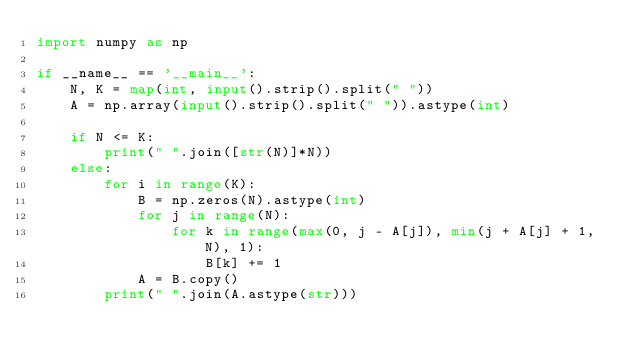<code> <loc_0><loc_0><loc_500><loc_500><_Python_>import numpy as np

if __name__ == '__main__':
    N, K = map(int, input().strip().split(" "))
    A = np.array(input().strip().split(" ")).astype(int)

    if N <= K:
        print(" ".join([str(N)]*N))
    else:
        for i in range(K):
            B = np.zeros(N).astype(int)
            for j in range(N):
                for k in range(max(0, j - A[j]), min(j + A[j] + 1, N), 1):
                    B[k] += 1
            A = B.copy()
        print(" ".join(A.astype(str)))
</code> 